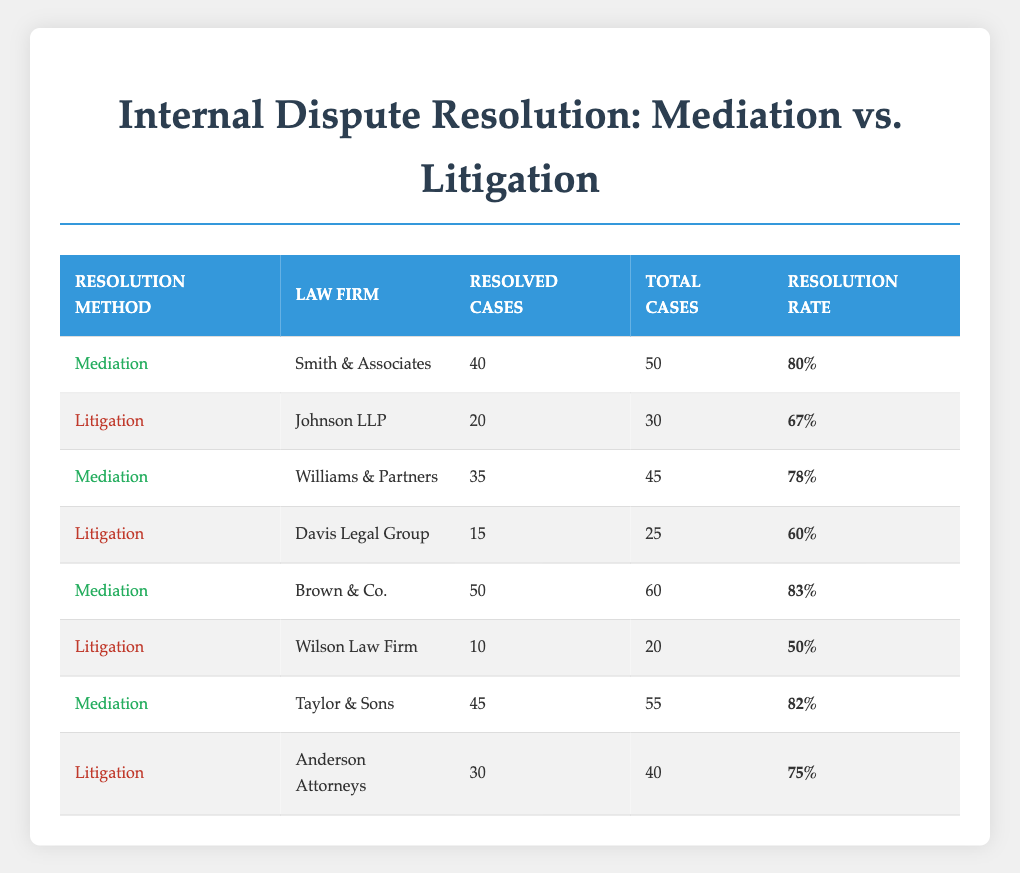What is the resolution rate for Smith & Associates? From the table, locate the row for Smith & Associates under the Mediation method. The resolution rate listed there is 80%.
Answer: 80% How many resolved cases did Wilson Law Firm have? By examining the table, find the row for Wilson Law Firm, which is under the Litigation method. The number of resolved cases is indicated as 10.
Answer: 10 What is the total of resolved cases for all firms using Mediation? First, identify all the firms that used the Mediation method: Smith & Associates (40), Williams & Partners (35), Brown & Co. (50), and Taylor & Sons (45). Add them up: 40 + 35 + 50 + 45 = 170.
Answer: 170 Is the resolution rate for Davis Legal Group higher than that of Johnson LLP? Check the rates in the table: Davis Legal Group has a resolution rate of 60%, while Johnson LLP has a rate of 67%. Since 60% is less than 67%, the answer is no.
Answer: No What is the average resolution rate for the firms that used Litigation? First, identify the firms that used Litigation and their rates: Johnson LLP (67%), Davis Legal Group (60%), Wilson Law Firm (50%), and Anderson Attorneys (75%). Add these rates: 67 + 60 + 50 + 75 = 252, then divide this sum by the number of firms (4) for the average: 252 / 4 = 63.
Answer: 63 Which firm had the highest resolution rate in the table? Review the resolution rates for all firms. The highest rate is 83% from Brown & Co. under Mediation.
Answer: Brown & Co What is the difference between the highest and lowest resolution rate for Mediation? Identify the highest resolution rate for Mediation (83% from Brown & Co.) and the lowest (78% from Williams & Partners). Calculate the difference: 83 - 78 = 5.
Answer: 5 Were there any firms in the table where the resolution rate exceeded 80%? Check the rates for each firm. Smith & Associates (80%), Brown & Co. (83%), and Taylor & Sons (82%) all exceed 80%. Since there are firms that meet this criterion, the answer is yes.
Answer: Yes 